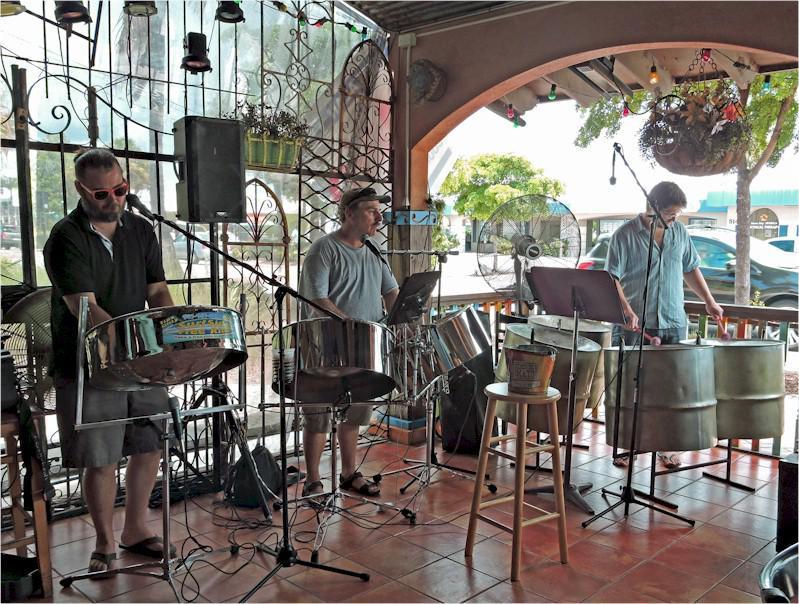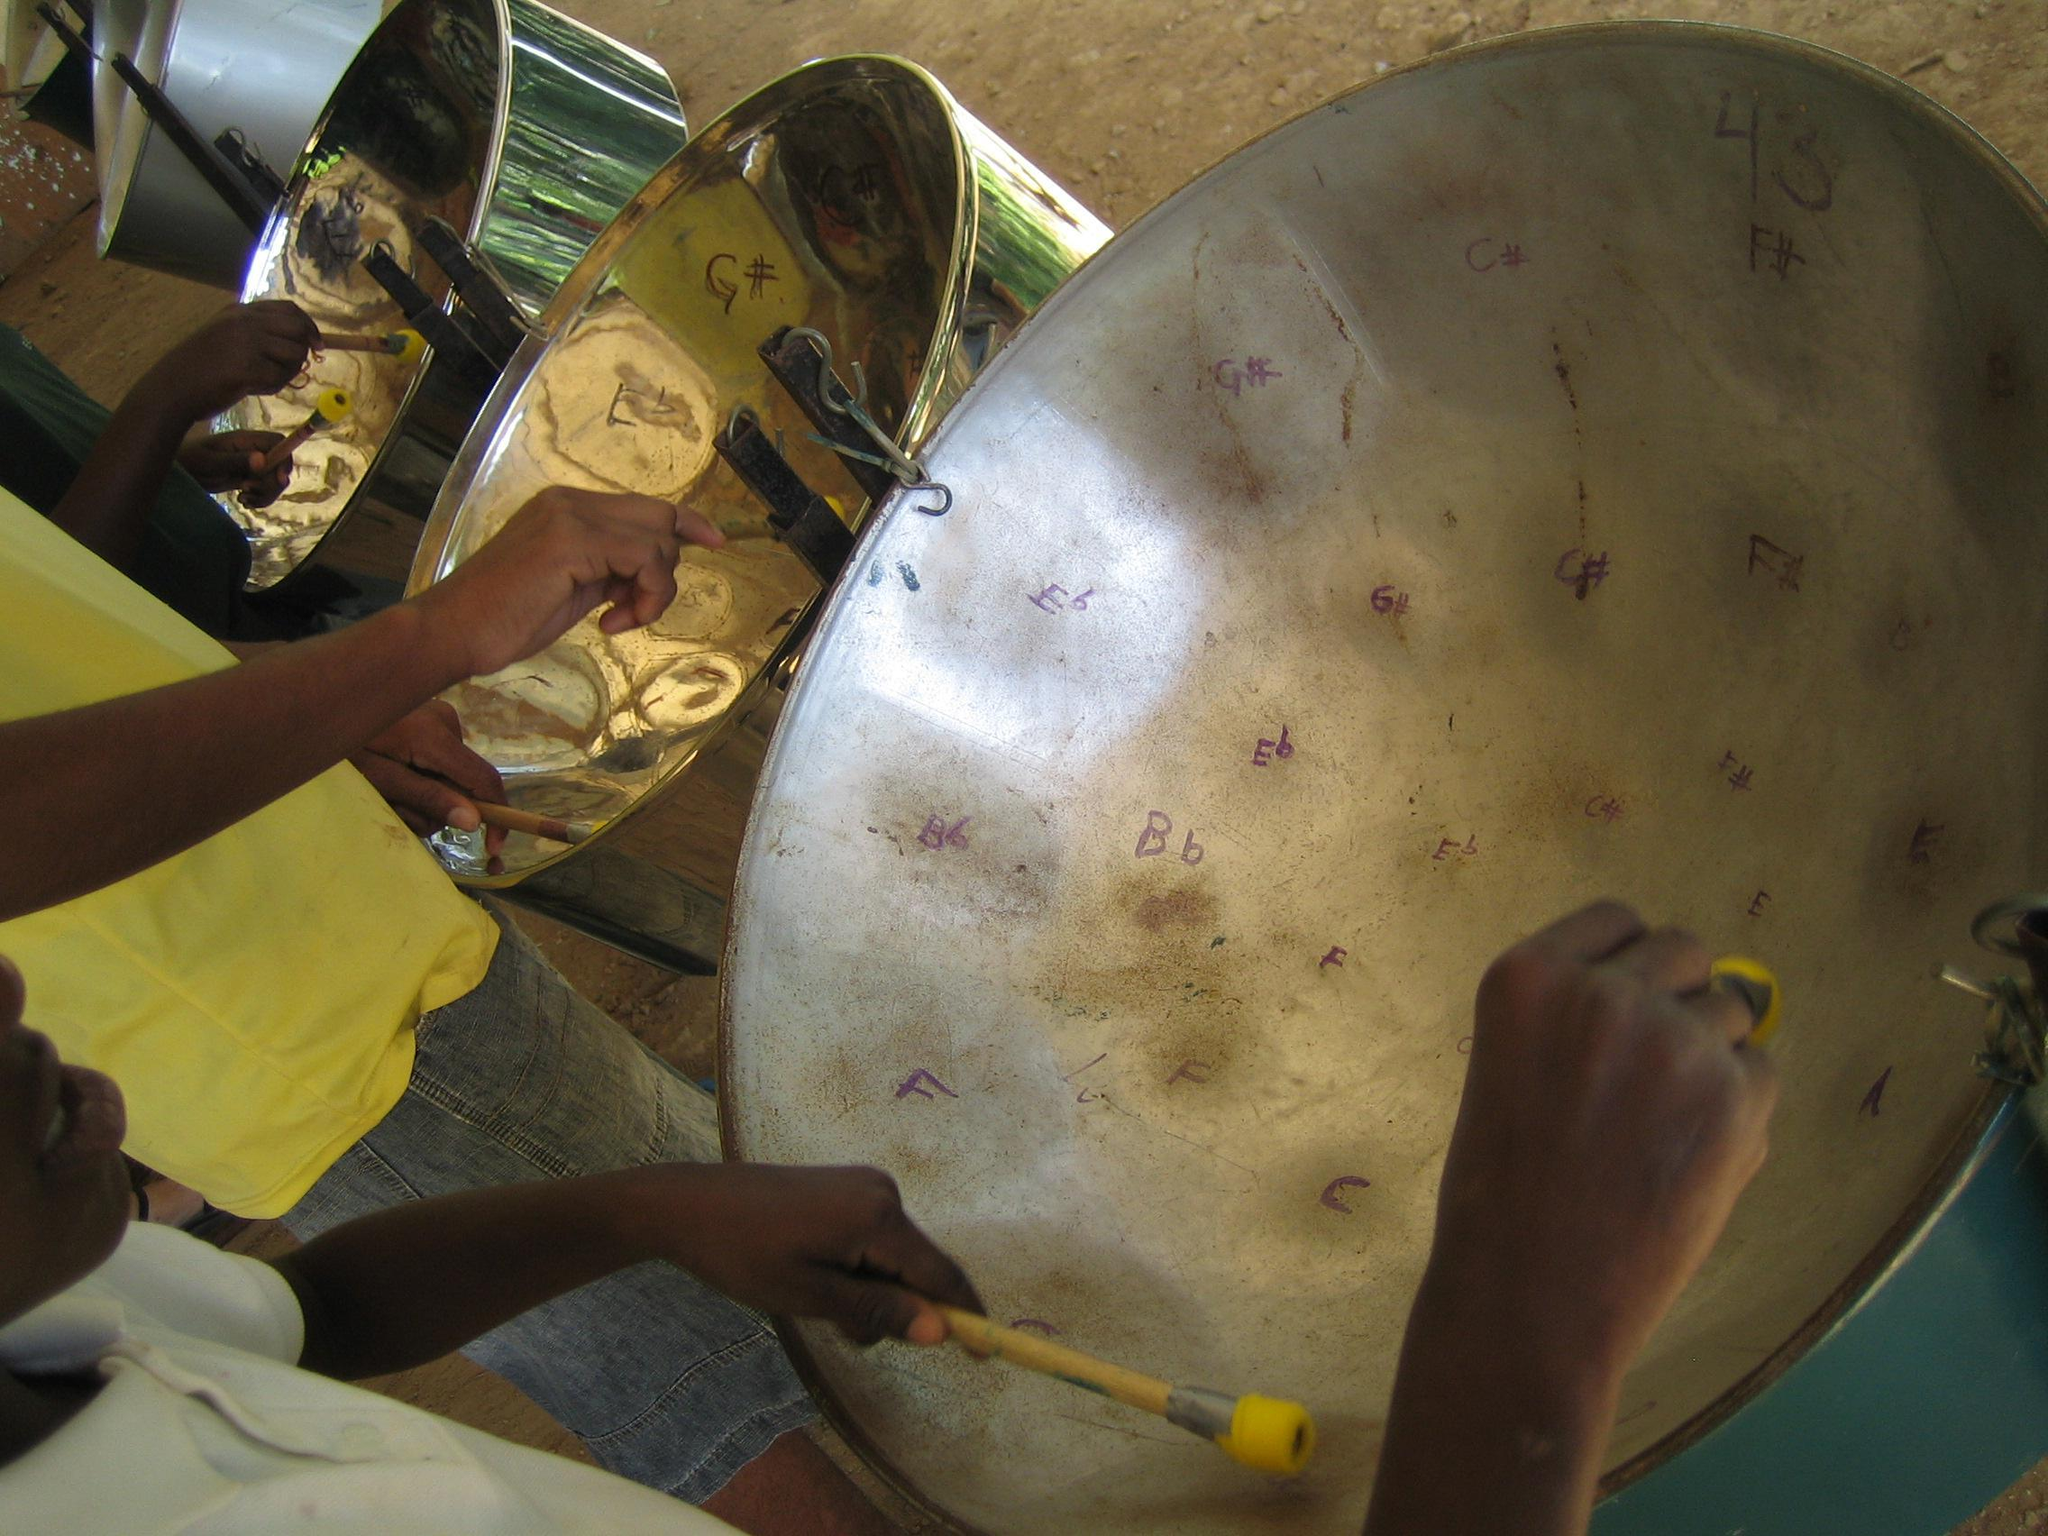The first image is the image on the left, the second image is the image on the right. For the images shown, is this caption "In at least one image there are three men playing metal drums." true? Answer yes or no. Yes. 